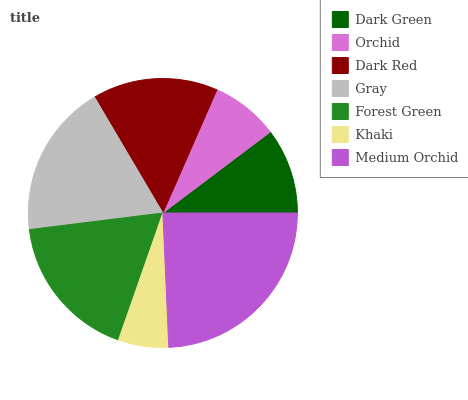Is Khaki the minimum?
Answer yes or no. Yes. Is Medium Orchid the maximum?
Answer yes or no. Yes. Is Orchid the minimum?
Answer yes or no. No. Is Orchid the maximum?
Answer yes or no. No. Is Dark Green greater than Orchid?
Answer yes or no. Yes. Is Orchid less than Dark Green?
Answer yes or no. Yes. Is Orchid greater than Dark Green?
Answer yes or no. No. Is Dark Green less than Orchid?
Answer yes or no. No. Is Dark Red the high median?
Answer yes or no. Yes. Is Dark Red the low median?
Answer yes or no. Yes. Is Orchid the high median?
Answer yes or no. No. Is Orchid the low median?
Answer yes or no. No. 